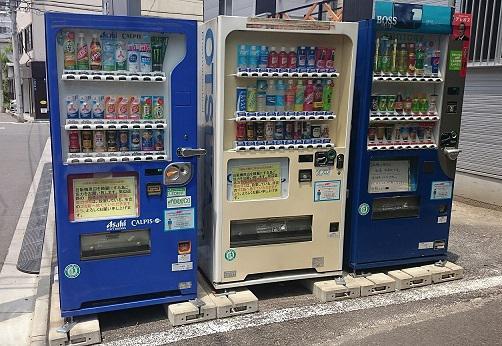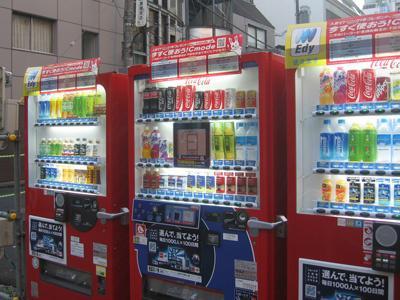The first image is the image on the left, the second image is the image on the right. For the images displayed, is the sentence "Each image has two or fewer vending machines." factually correct? Answer yes or no. No. 